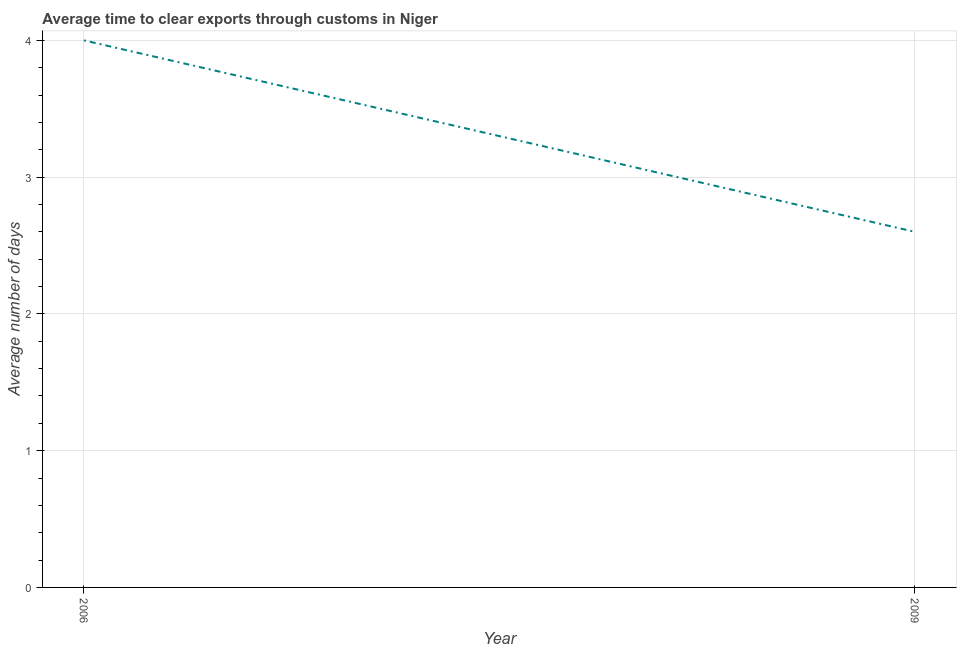What is the difference between the time to clear exports through customs in 2006 and 2009?
Your answer should be very brief. 1.4. What is the median time to clear exports through customs?
Give a very brief answer. 3.3. Do a majority of the years between 2009 and 2006 (inclusive) have time to clear exports through customs greater than 1.4 days?
Provide a succinct answer. No. What is the ratio of the time to clear exports through customs in 2006 to that in 2009?
Your response must be concise. 1.54. Does the time to clear exports through customs monotonically increase over the years?
Give a very brief answer. No. How many lines are there?
Offer a terse response. 1. How many years are there in the graph?
Ensure brevity in your answer.  2. What is the difference between two consecutive major ticks on the Y-axis?
Offer a very short reply. 1. Are the values on the major ticks of Y-axis written in scientific E-notation?
Your answer should be very brief. No. Does the graph contain grids?
Provide a succinct answer. Yes. What is the title of the graph?
Provide a short and direct response. Average time to clear exports through customs in Niger. What is the label or title of the Y-axis?
Make the answer very short. Average number of days. What is the difference between the Average number of days in 2006 and 2009?
Offer a terse response. 1.4. What is the ratio of the Average number of days in 2006 to that in 2009?
Offer a terse response. 1.54. 